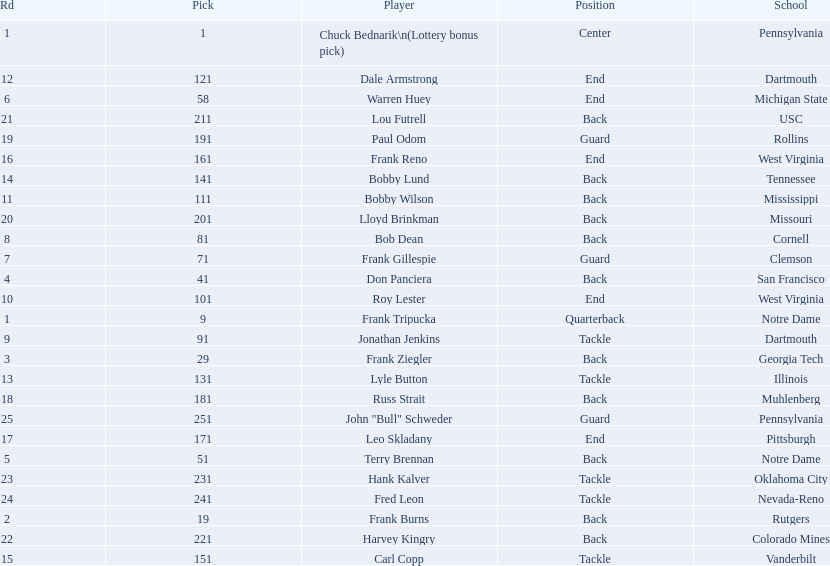Highest rd number? 25. 